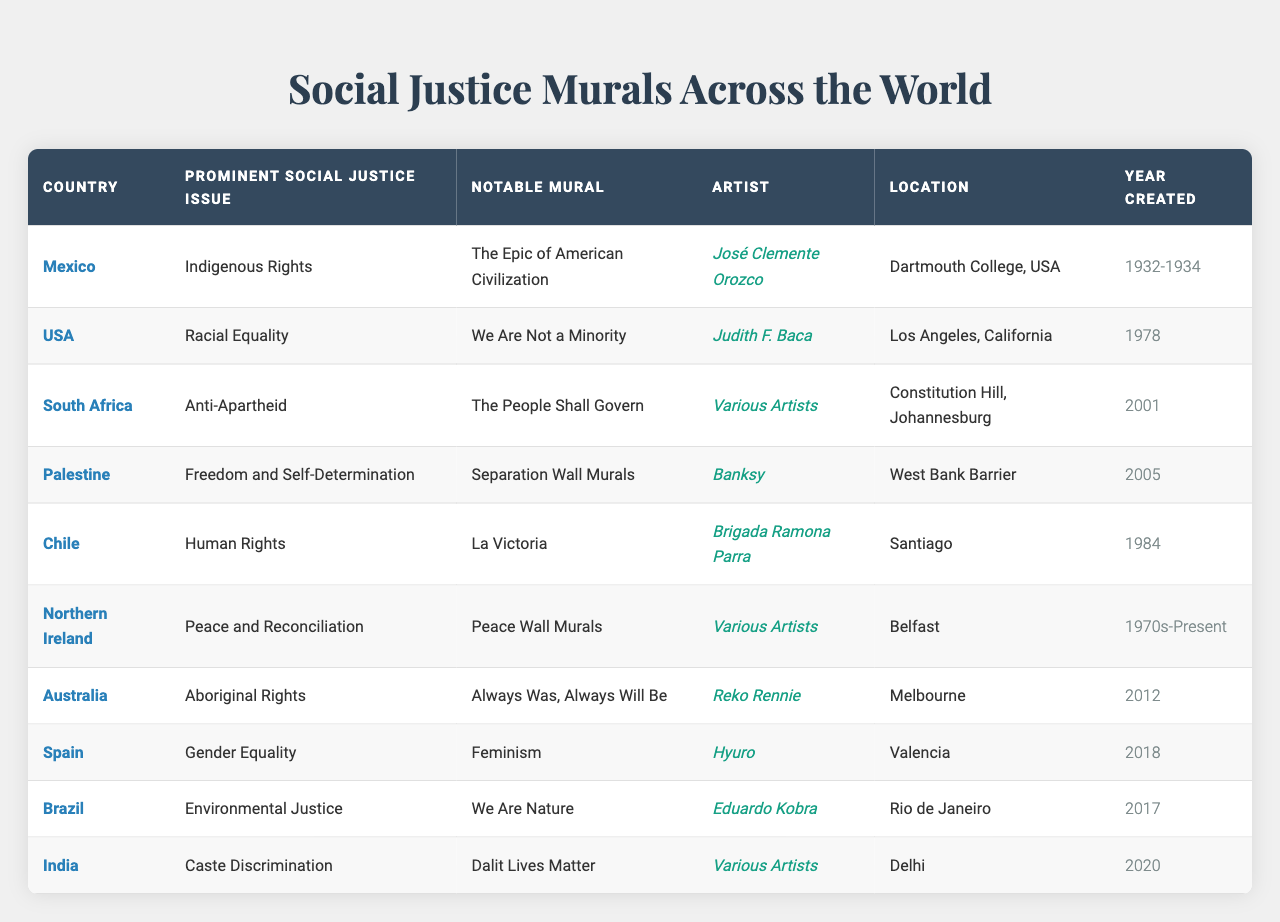What social justice issue is addressed in the mural "We Are Not a Minority"? Referring to the table, the mural "We Are Not a Minority" is associated with the social justice issue of racial equality.
Answer: Racial equality Which artist created the mural "Always Was, Always Will Be"? The table shows that the mural "Always Was, Always Will Be" was created by the artist Reko Rennie.
Answer: Reko Rennie In which country were notable murals created by various artists addressing peace and reconciliation? The table indicates that the notable murals addressing peace and reconciliation were created in Northern Ireland.
Answer: Northern Ireland What year was the mural "The Epic of American Civilization" completed? According to the table, "The Epic of American Civilization" was completed in the year range of 1932 to 1934.
Answer: 1932-1934 How many murals were created in the 2000s? Looking at the years listed, there are three murals created in the 2000s: "The People Shall Govern" (2001), "Separation Wall Murals" (2005), and "Dalit Lives Matter" (2020). Therefore, the total is 3.
Answer: 3 Is the mural "La Victoria" focused on environmental justice? According to the table, "La Victoria" addresses the social justice issue of human rights, not environmental justice.
Answer: No Which mural was created to highlight the issue of indigenous rights, and where is it located? The mural "The Epic of American Civilization" highlights the issue of indigenous rights and is located at Dartmouth College in the USA.
Answer: The Epic of American Civilization, Dartmouth College, USA Identify the only mural that addresses gender equality and its location. The table lists "Feminism" as the mural addressing gender equality, located in Valencia, Spain.
Answer: Feminism, Valencia How many social justice issues are represented in murals from South America based on the table? The table presents two social justice issues in South America: human rights in Chile and environmental justice in Brazil. Thus, there are 2 issues.
Answer: 2 Which country's mural depicts the theme of freedom and self-determination, and who is the artist? The table indicates that Palestine's mural focusing on freedom and self-determination is the "Separation Wall Murals," by artist Banksy.
Answer: Palestine, Banksy 